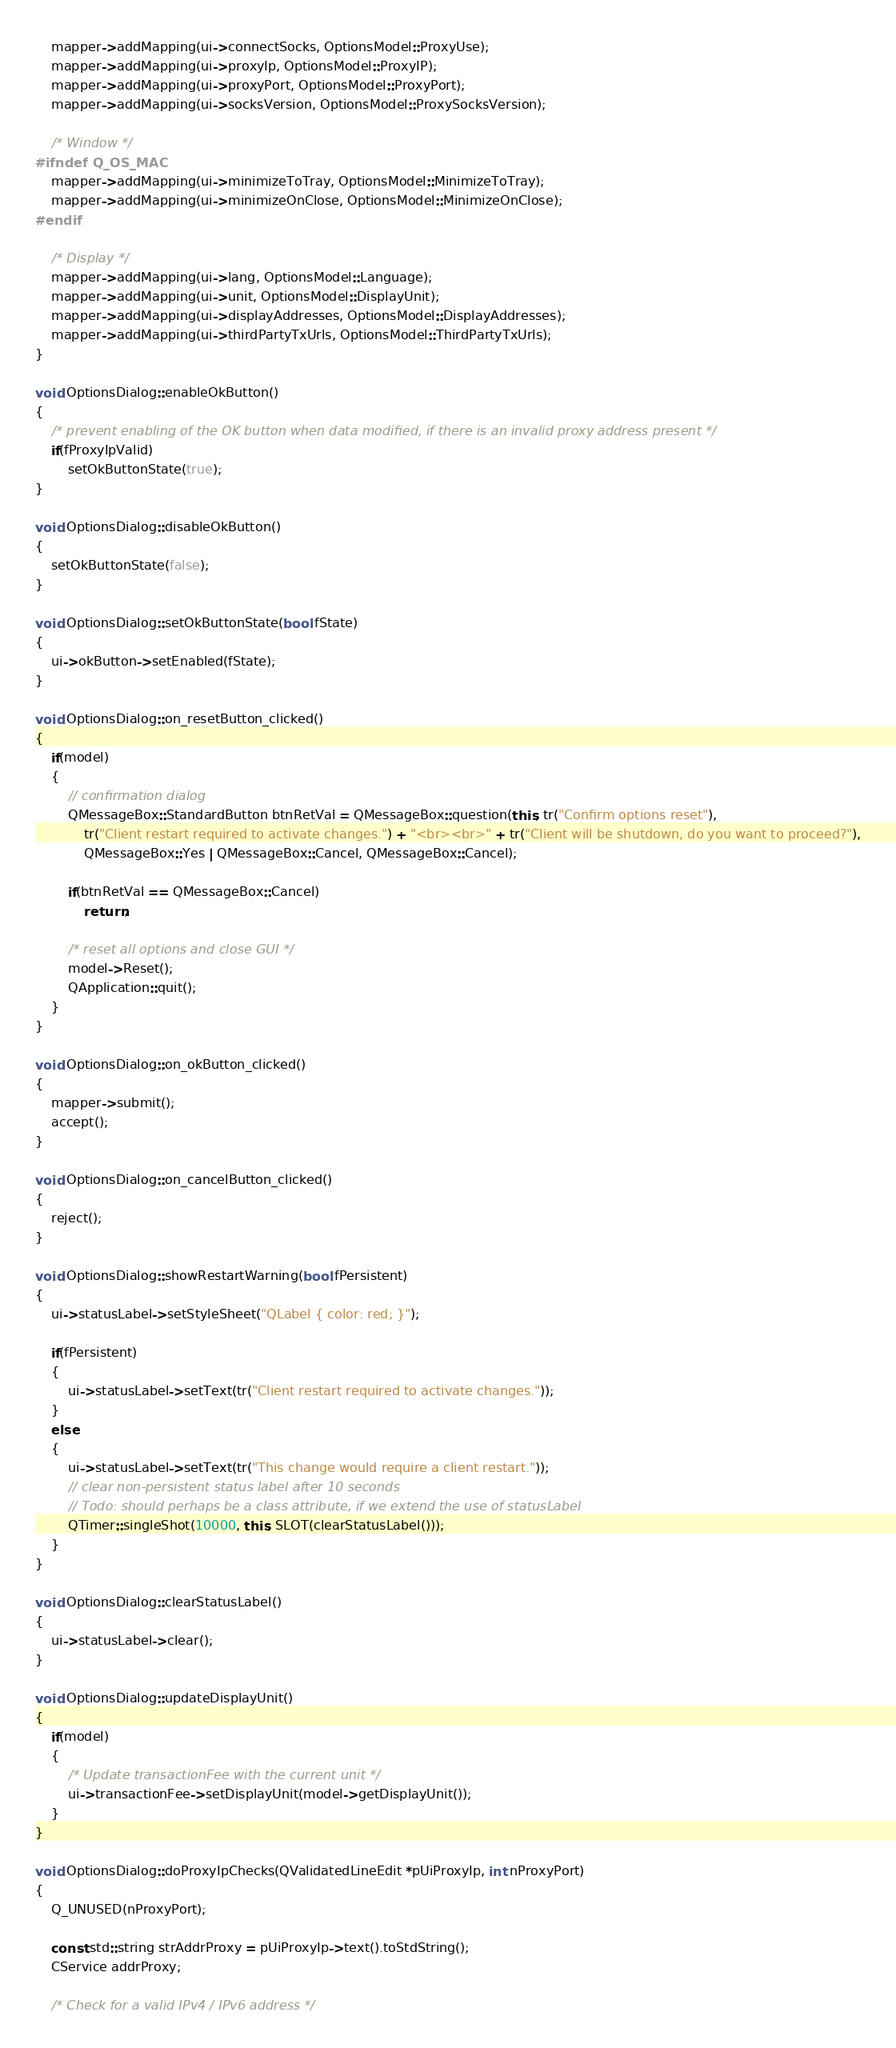<code> <loc_0><loc_0><loc_500><loc_500><_C++_>
    mapper->addMapping(ui->connectSocks, OptionsModel::ProxyUse);
    mapper->addMapping(ui->proxyIp, OptionsModel::ProxyIP);
    mapper->addMapping(ui->proxyPort, OptionsModel::ProxyPort);
    mapper->addMapping(ui->socksVersion, OptionsModel::ProxySocksVersion);

    /* Window */
#ifndef Q_OS_MAC
    mapper->addMapping(ui->minimizeToTray, OptionsModel::MinimizeToTray);
    mapper->addMapping(ui->minimizeOnClose, OptionsModel::MinimizeOnClose);
#endif

    /* Display */
    mapper->addMapping(ui->lang, OptionsModel::Language);
    mapper->addMapping(ui->unit, OptionsModel::DisplayUnit);
    mapper->addMapping(ui->displayAddresses, OptionsModel::DisplayAddresses);
    mapper->addMapping(ui->thirdPartyTxUrls, OptionsModel::ThirdPartyTxUrls);
}

void OptionsDialog::enableOkButton()
{
    /* prevent enabling of the OK button when data modified, if there is an invalid proxy address present */
    if(fProxyIpValid)
        setOkButtonState(true);
}

void OptionsDialog::disableOkButton()
{
    setOkButtonState(false);
}

void OptionsDialog::setOkButtonState(bool fState)
{
    ui->okButton->setEnabled(fState);
}

void OptionsDialog::on_resetButton_clicked()
{
    if(model)
    {
        // confirmation dialog
        QMessageBox::StandardButton btnRetVal = QMessageBox::question(this, tr("Confirm options reset"),
            tr("Client restart required to activate changes.") + "<br><br>" + tr("Client will be shutdown, do you want to proceed?"),
            QMessageBox::Yes | QMessageBox::Cancel, QMessageBox::Cancel);

        if(btnRetVal == QMessageBox::Cancel)
            return;

        /* reset all options and close GUI */
        model->Reset();
        QApplication::quit();
    }
}

void OptionsDialog::on_okButton_clicked()
{
    mapper->submit();
    accept();
}

void OptionsDialog::on_cancelButton_clicked()
{
    reject();
}

void OptionsDialog::showRestartWarning(bool fPersistent)
{
    ui->statusLabel->setStyleSheet("QLabel { color: red; }");

    if(fPersistent)
    {
        ui->statusLabel->setText(tr("Client restart required to activate changes."));
    }
    else
    {
        ui->statusLabel->setText(tr("This change would require a client restart."));
        // clear non-persistent status label after 10 seconds
        // Todo: should perhaps be a class attribute, if we extend the use of statusLabel
        QTimer::singleShot(10000, this, SLOT(clearStatusLabel()));
    }
}

void OptionsDialog::clearStatusLabel()
{
    ui->statusLabel->clear();
}

void OptionsDialog::updateDisplayUnit()
{
    if(model)
    {
        /* Update transactionFee with the current unit */
        ui->transactionFee->setDisplayUnit(model->getDisplayUnit());
    }
}

void OptionsDialog::doProxyIpChecks(QValidatedLineEdit *pUiProxyIp, int nProxyPort)
{
    Q_UNUSED(nProxyPort);

    const std::string strAddrProxy = pUiProxyIp->text().toStdString();
    CService addrProxy;

    /* Check for a valid IPv4 / IPv6 address */</code> 